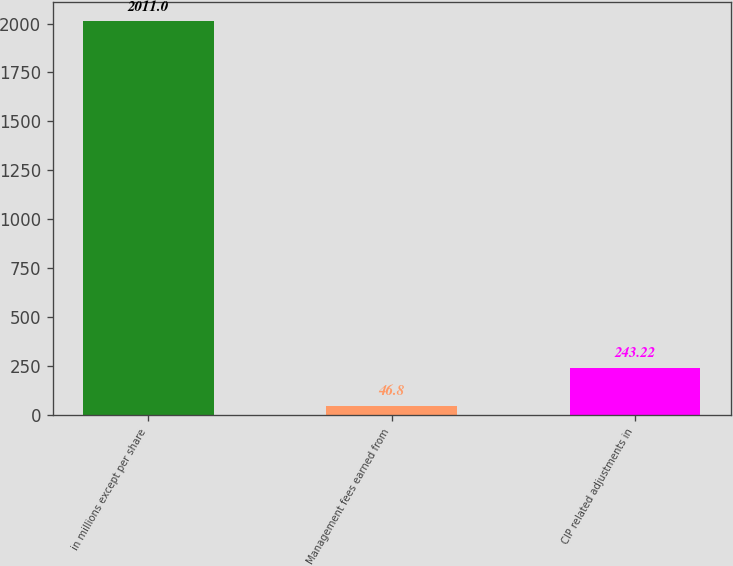Convert chart. <chart><loc_0><loc_0><loc_500><loc_500><bar_chart><fcel>in millions except per share<fcel>Management fees earned from<fcel>CIP related adjustments in<nl><fcel>2011<fcel>46.8<fcel>243.22<nl></chart> 